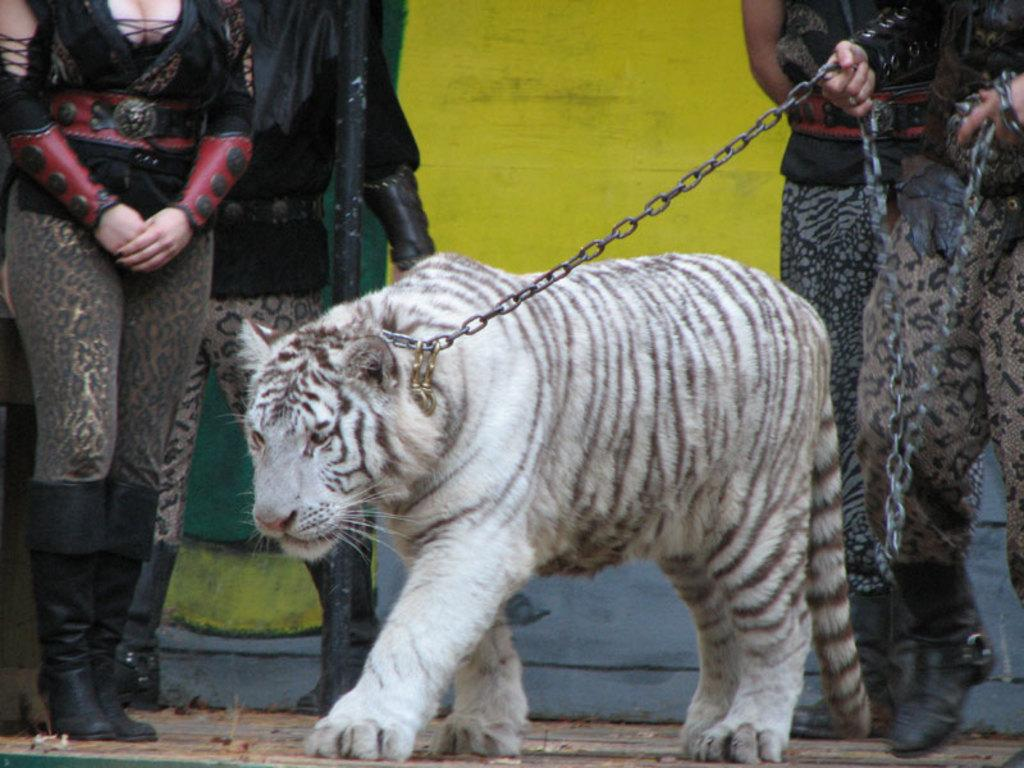What is the person holding in the image? The person is holding a white tiger with a chain. Are there any other people present in the image? Yes, there are people standing behind the person holding the tiger. What can be seen in the background of the image? There is a wall in the background. What type of blood is visible on the wall in the image? There is no blood visible on the wall in the image. 